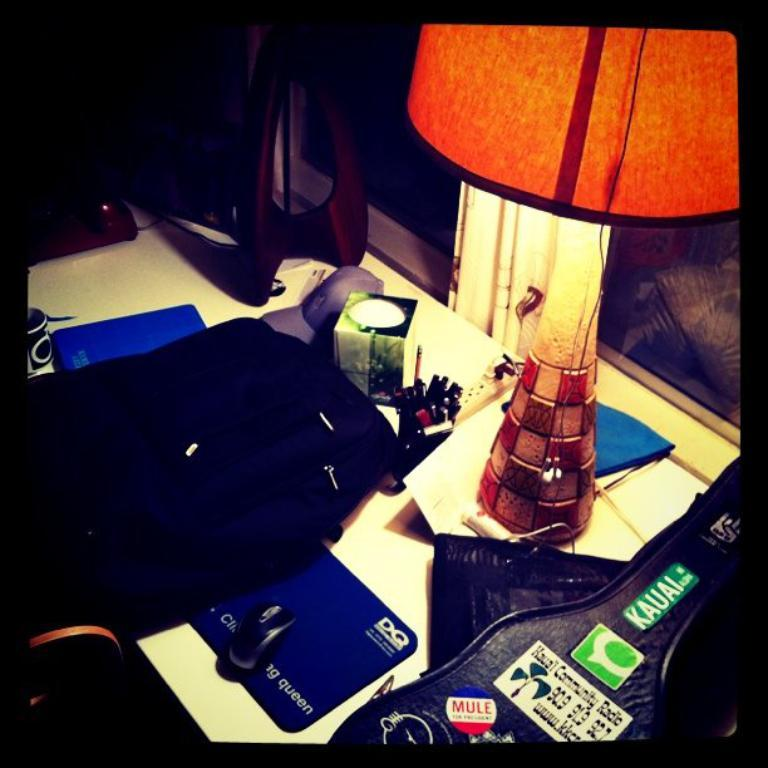What piece of furniture is present in the image? There is a table in the image. What object is placed on the table? There is a lamp on the table. Can you describe any other items that are on the table? There are other unspecified items on the table. What type of beef is being served on the table in the image? There is no beef present in the image; it only features a table, a lamp, and unspecified items. 